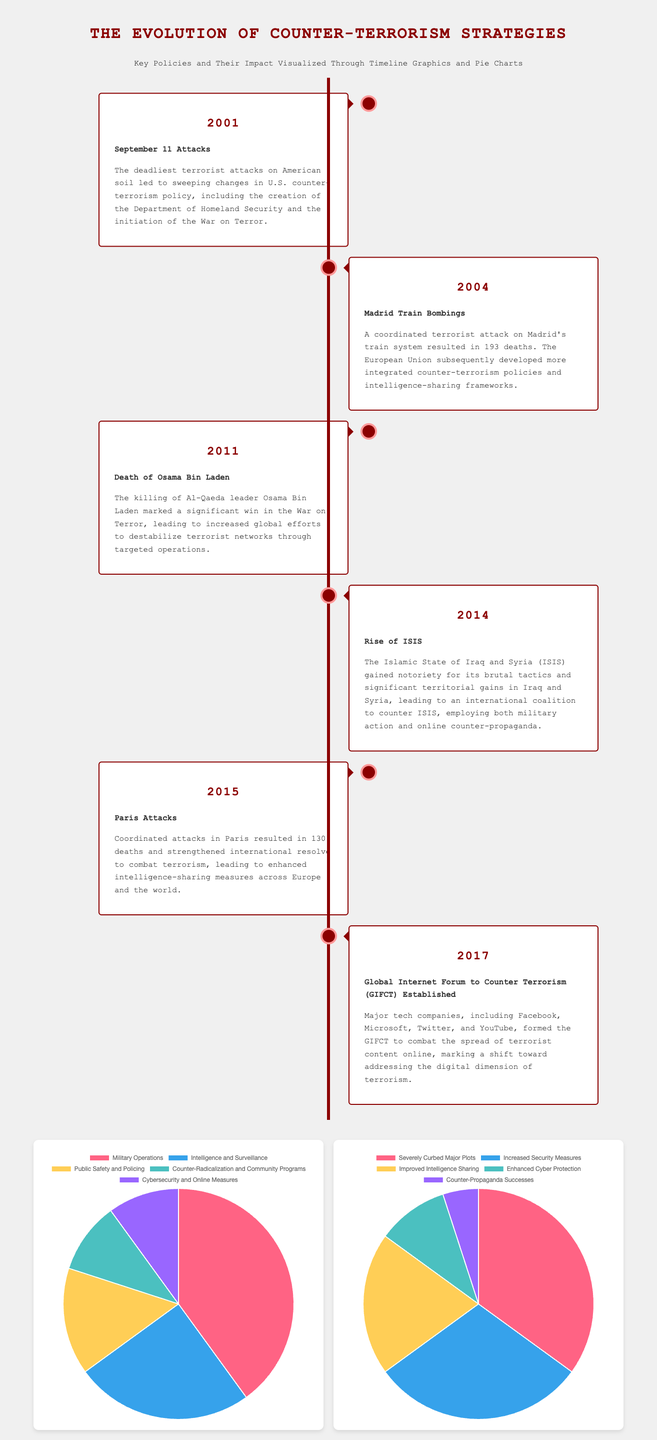What year did the September 11 attacks occur? The timeline indicates that the September 11 attacks occurred in the year 2001.
Answer: 2001 What was one significant result of the 2004 Madrid train bombings? The document states that the European Union developed more integrated counter-terrorism policies and intelligence-sharing frameworks as a result of the bombings.
Answer: Integrated policies What year was Osama Bin Laden killed? The document mentions that Osama Bin Laden was killed in 2011.
Answer: 2011 What percentage of counter-terrorism funding is allocated to Military Operations? The pie chart shows that 40 percent of the funding is allocated to Military Operations.
Answer: 40% Which event led to the establishment of the Global Internet Forum to Counter Terrorism? The document notes that the establishment of the Global Internet Forum to Counter Terrorism was a response to the changing dynamics of terrorism, particularly online.
Answer: Rise of ISIS What is the impact percentage of “Counter-Propaganda Successes”? The pie chart specifies that the impact percentage of “Counter-Propaganda Successes” is 5 percent.
Answer: 5% What key policy was created in response to the September 11 attacks? The document highlights the creation of the Department of Homeland Security as a key policy change following the attacks.
Answer: Department of Homeland Security What year did the Paris attacks occur? According to the timeline, the Paris attacks occurred in 2015.
Answer: 2015 Which type of counter-terrorism effort received the least funding in 2023? The document indicates that Counter-Radicalization and Community Programs received the least funding at 10 percent.
Answer: Counter-Radicalization and Community Programs What major shift in counter-terrorism strategies was noted in 2017? The establishment of the Global Internet Forum to Counter Terrorism marked a shift towards addressing the digital dimension of terrorism.
Answer: Digital dimension 